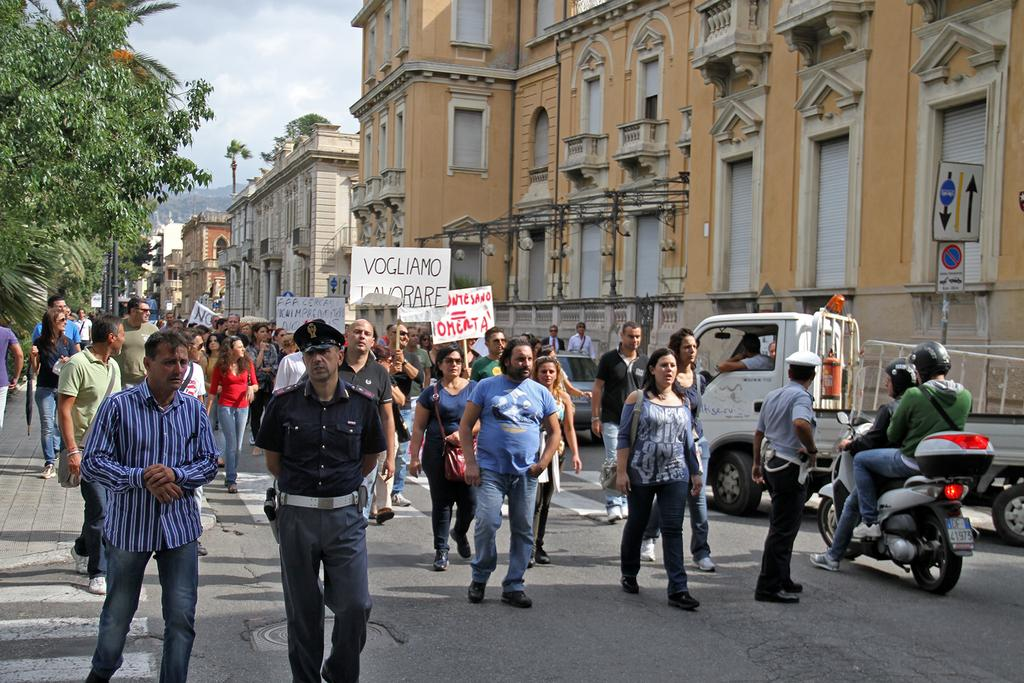What are the people in the image doing? The people in the image are holding placards and walking. What can be seen on the road in the image? There are vehicles on the road in the image. What is attached to a building in the image? There is a sign board attached to a building in the image. What type of vegetation is present in the image? There are trees present in the image. What is the chance of a frog hopping across the placards in the image? There is no frog present in the image, so it is not possible to determine the chance of a frog hopping across the placards. 